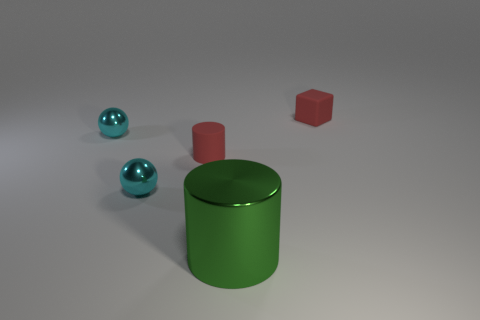Subtract all cylinders. How many objects are left? 3 Add 4 tiny red rubber cylinders. How many objects exist? 9 Subtract all yellow cylinders. Subtract all red balls. How many cylinders are left? 2 Subtract all yellow cubes. How many red cylinders are left? 1 Subtract all red things. Subtract all cyan things. How many objects are left? 1 Add 4 tiny metallic balls. How many tiny metallic balls are left? 6 Add 3 tiny cyan metal spheres. How many tiny cyan metal spheres exist? 5 Subtract 0 green blocks. How many objects are left? 5 